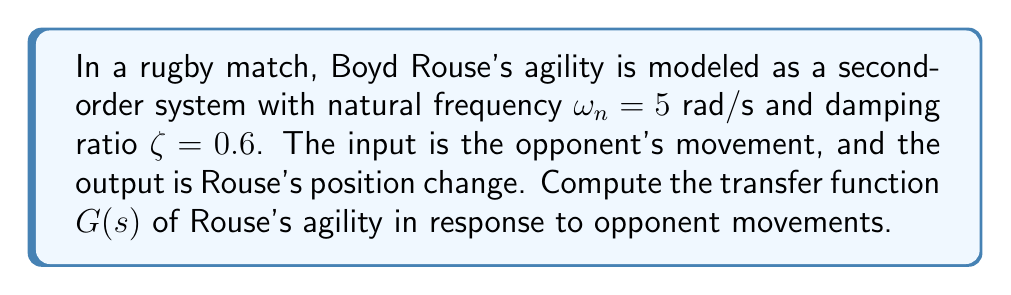Give your solution to this math problem. To solve this problem, we'll follow these steps:

1) The general form of a second-order transfer function is:

   $$G(s) = \frac{\omega_n^2}{s^2 + 2\zeta\omega_n s + \omega_n^2}$$

2) We're given:
   - Natural frequency: $\omega_n = 5$ rad/s
   - Damping ratio: $\zeta = 0.6$

3) Let's substitute these values into the general form:

   $$G(s) = \frac{5^2}{s^2 + 2(0.6)(5)s + 5^2}$$

4) Simplify:
   $$G(s) = \frac{25}{s^2 + 6s + 25}$$

This transfer function represents how Boyd Rouse's position (output) changes in response to the opponent's movement (input). The denominator represents the characteristic equation of the system, which determines its dynamic behavior.

The natural frequency $\omega_n = 5$ rad/s indicates how quickly Rouse can respond to changes, while the damping ratio $\zeta = 0.6$ suggests a slightly underdamped system, allowing for quick reactions with minimal overshoot - ideal for a rugby player's agility.
Answer: $$G(s) = \frac{25}{s^2 + 6s + 25}$$ 